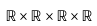<formula> <loc_0><loc_0><loc_500><loc_500>\mathbb { R } \times \mathbb { R } \times \mathbb { R } \times \mathbb { R }</formula> 